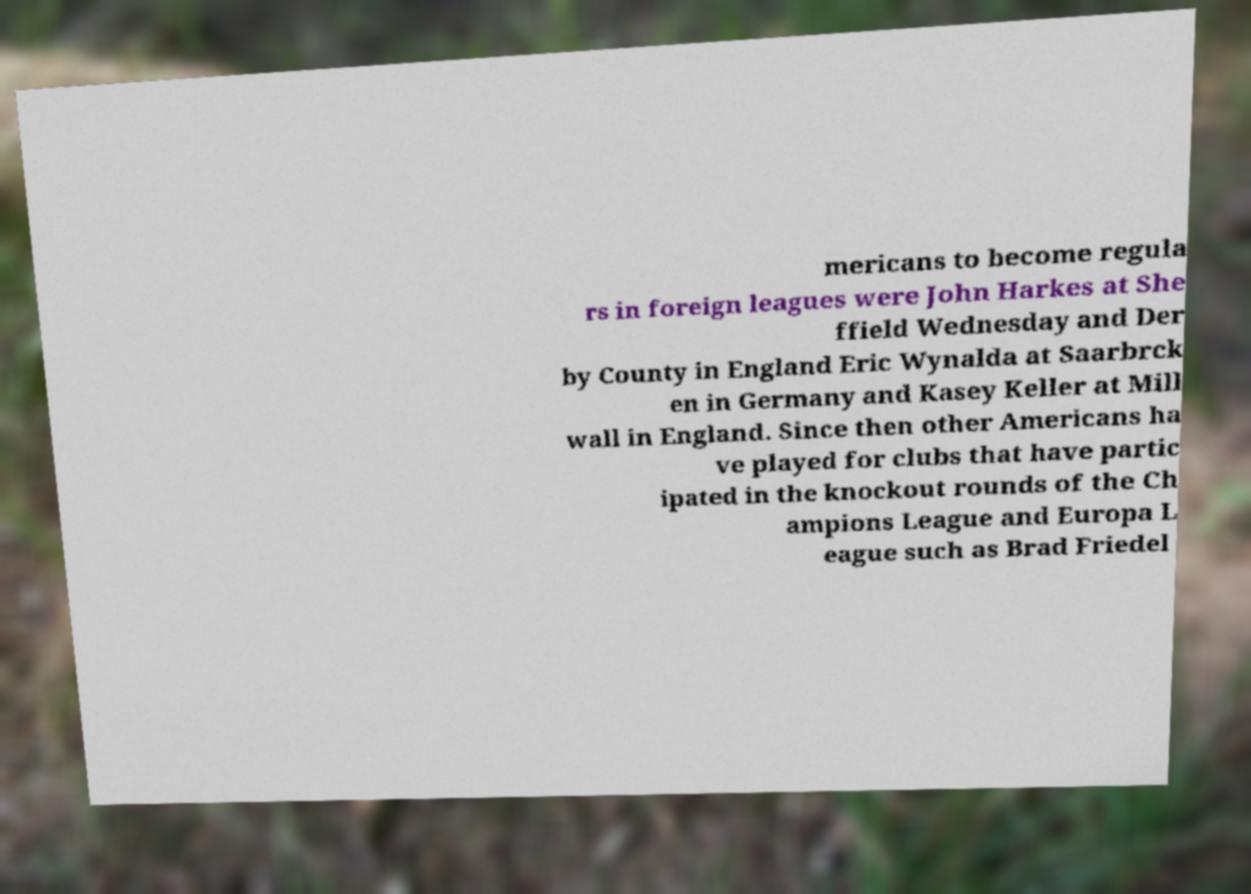Please identify and transcribe the text found in this image. mericans to become regula rs in foreign leagues were John Harkes at She ffield Wednesday and Der by County in England Eric Wynalda at Saarbrck en in Germany and Kasey Keller at Mill wall in England. Since then other Americans ha ve played for clubs that have partic ipated in the knockout rounds of the Ch ampions League and Europa L eague such as Brad Friedel 